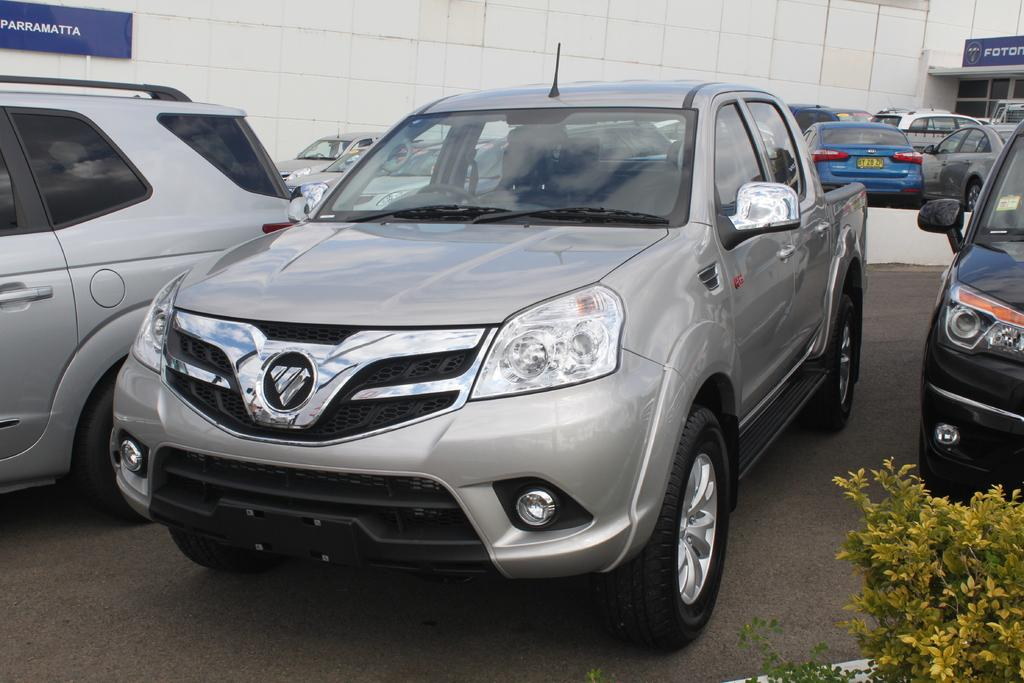What is the main subject in the center of the image? There is a car in the center of the image. Are there any other cars visible in the image? Yes, there are other cars on the right side and the left side of the image. What type of polish is being applied to the news in the image? There is no polish or news present in the image; it only features cars. 